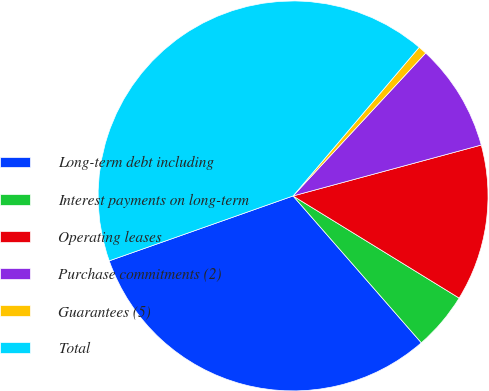Convert chart to OTSL. <chart><loc_0><loc_0><loc_500><loc_500><pie_chart><fcel>Long-term debt including<fcel>Interest payments on long-term<fcel>Operating leases<fcel>Purchase commitments (2)<fcel>Guarantees (5)<fcel>Total<nl><fcel>31.03%<fcel>4.8%<fcel>12.98%<fcel>8.89%<fcel>0.71%<fcel>41.6%<nl></chart> 